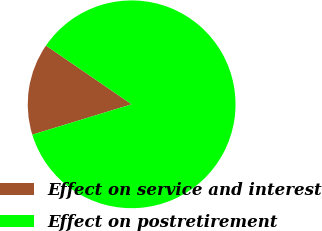Convert chart to OTSL. <chart><loc_0><loc_0><loc_500><loc_500><pie_chart><fcel>Effect on service and interest<fcel>Effect on postretirement<nl><fcel>14.29%<fcel>85.71%<nl></chart> 